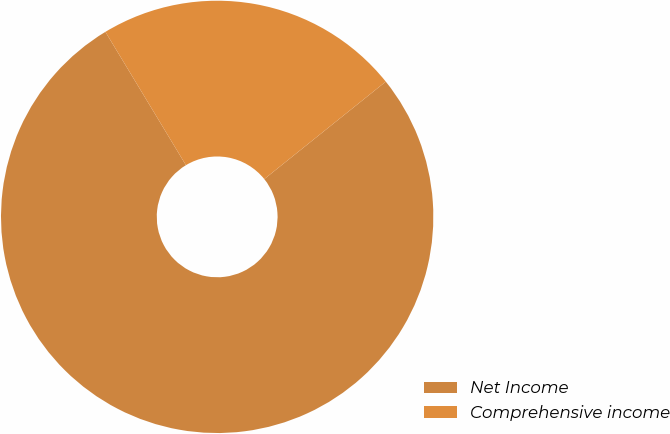Convert chart to OTSL. <chart><loc_0><loc_0><loc_500><loc_500><pie_chart><fcel>Net Income<fcel>Comprehensive income<nl><fcel>77.11%<fcel>22.89%<nl></chart> 